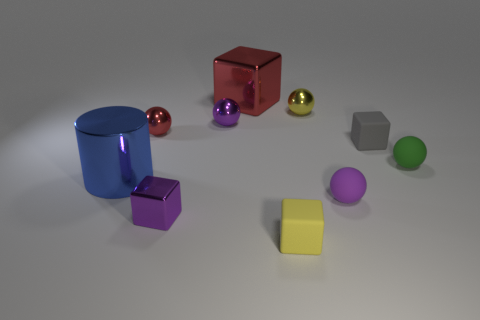What is the material of the tiny yellow thing that is the same shape as the small red thing? metal 